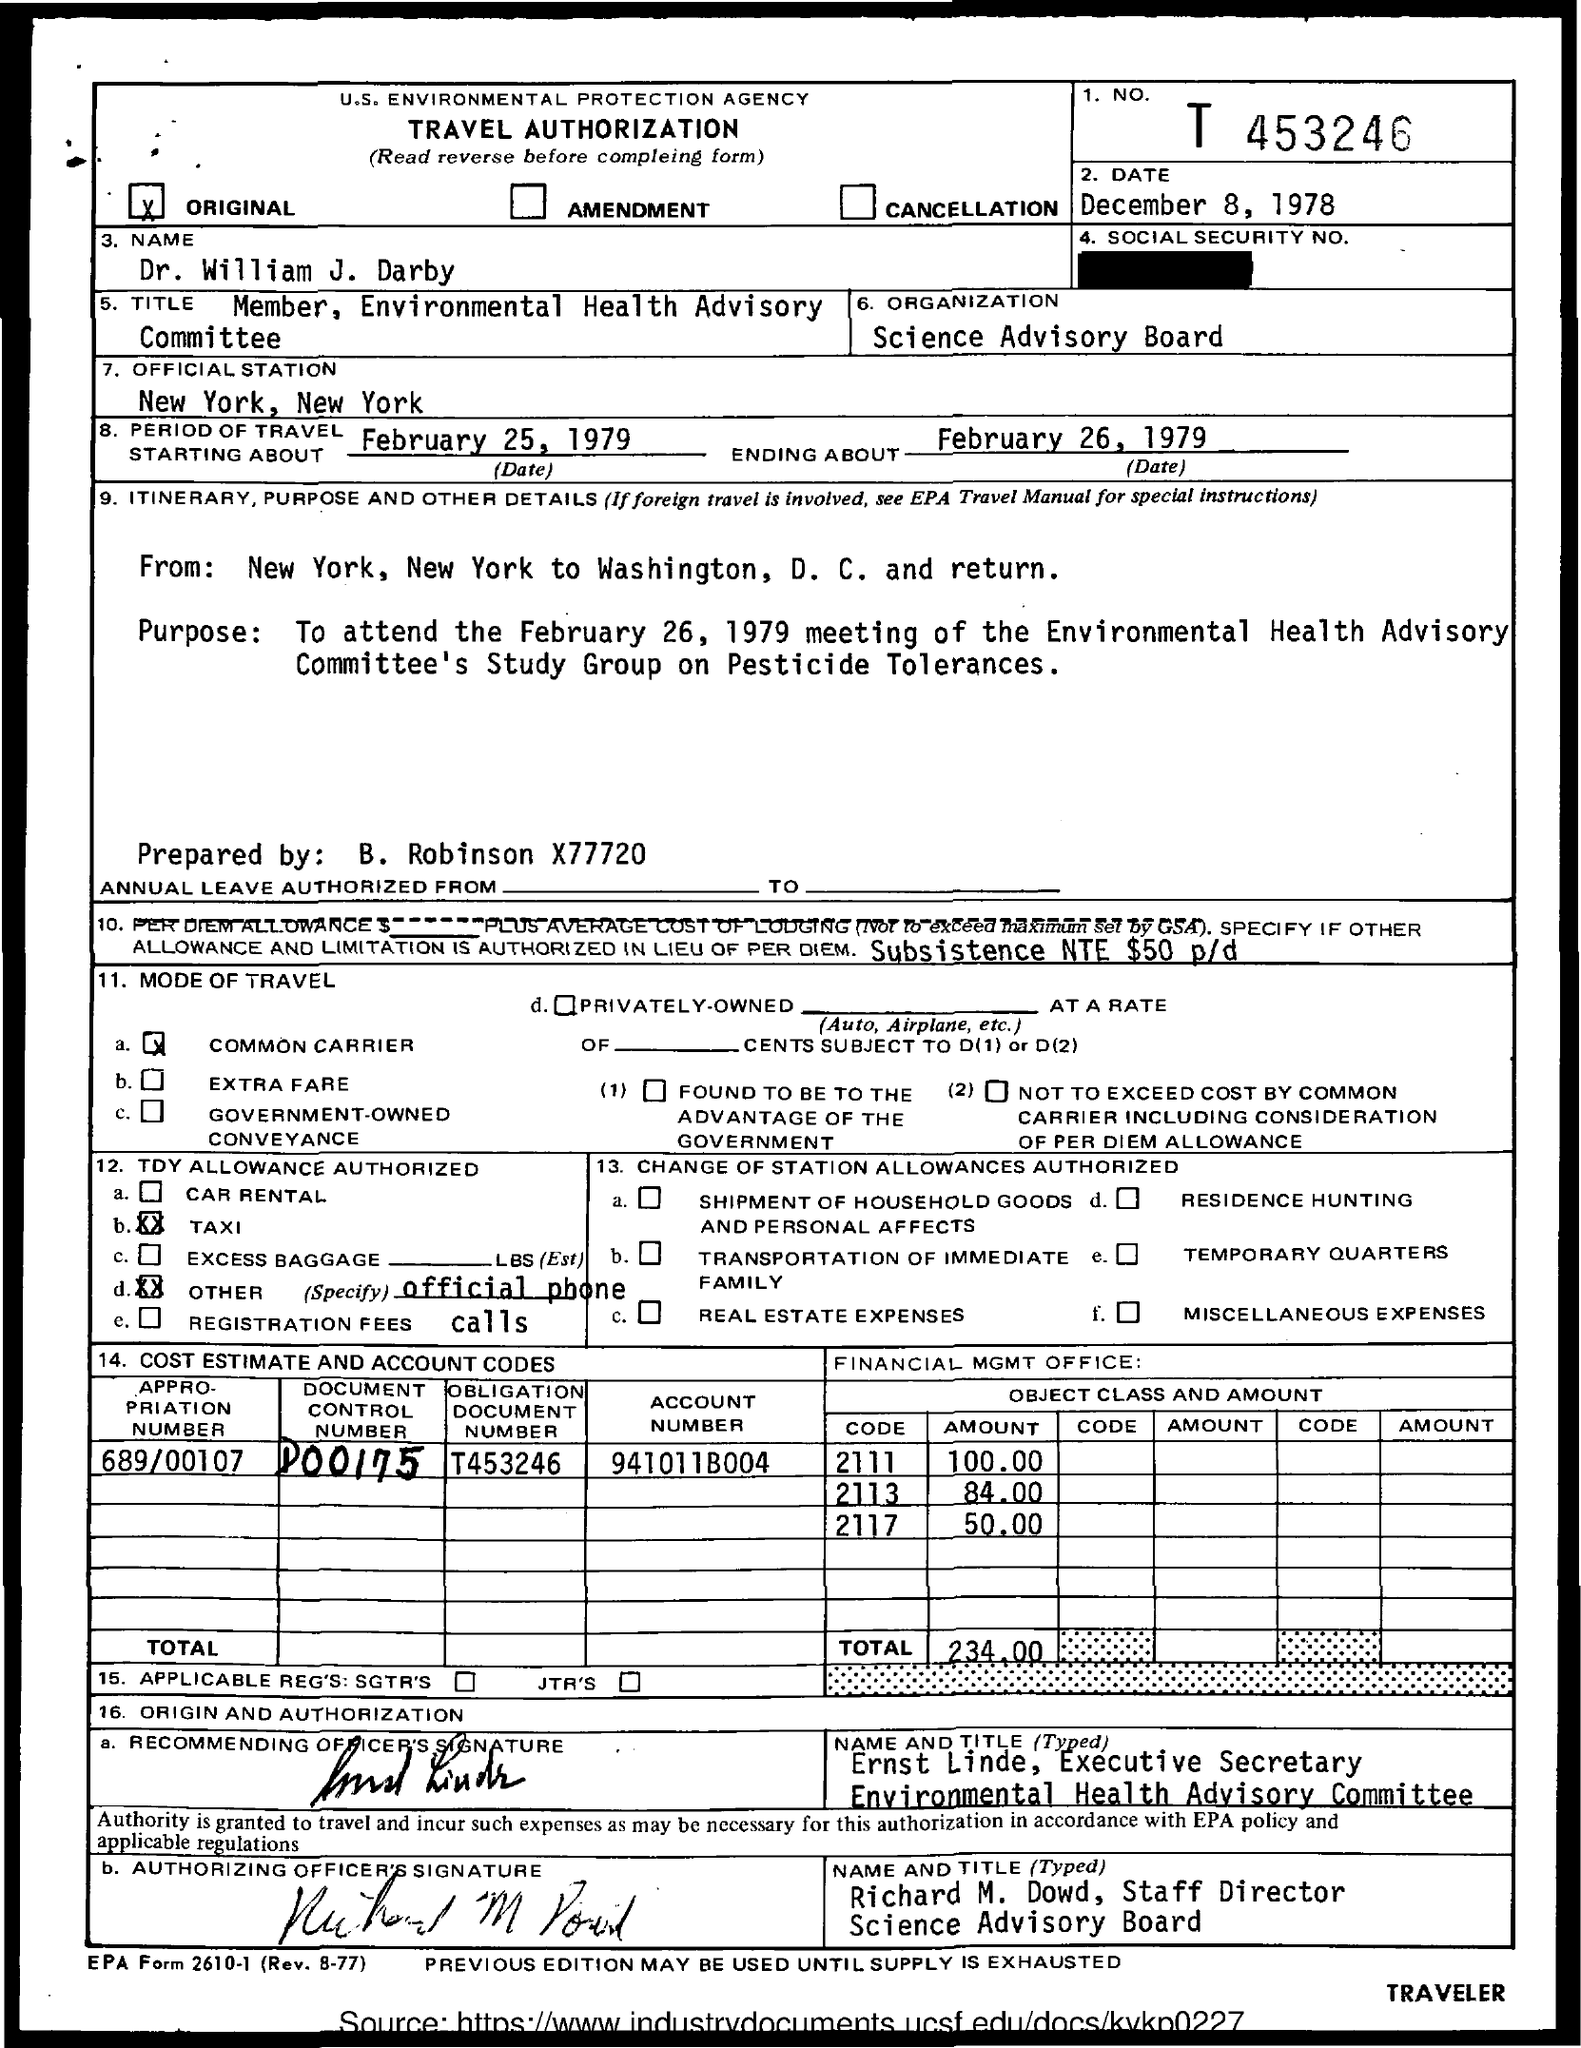What is the Account Number?
Offer a terse response. 941011B004. What is the Obligation Document Number?
Ensure brevity in your answer.  T453246. What is the Appropriation Number?
Make the answer very short. 689/00107. What is the Document Control Number?
Your answer should be very brief. D00175. What is the total amount?
Your response must be concise. 234.00. What is the amount with code 2111?
Ensure brevity in your answer.  100.00. Where is the Official Station?
Offer a terse response. New york, new york. What is the name of the Organization?
Keep it short and to the point. Science Advisory Board. 